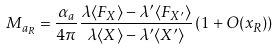<formula> <loc_0><loc_0><loc_500><loc_500>M _ { a _ { R } } = \frac { \alpha _ { a } } { 4 \pi } \frac { \lambda \langle F _ { X } \rangle - \lambda ^ { \prime } \langle F _ { X ^ { \prime } } \rangle } { \lambda \langle X \rangle - \lambda ^ { \prime } \langle X ^ { \prime } \rangle } \left ( 1 + O ( x _ { R } ) \right )</formula> 